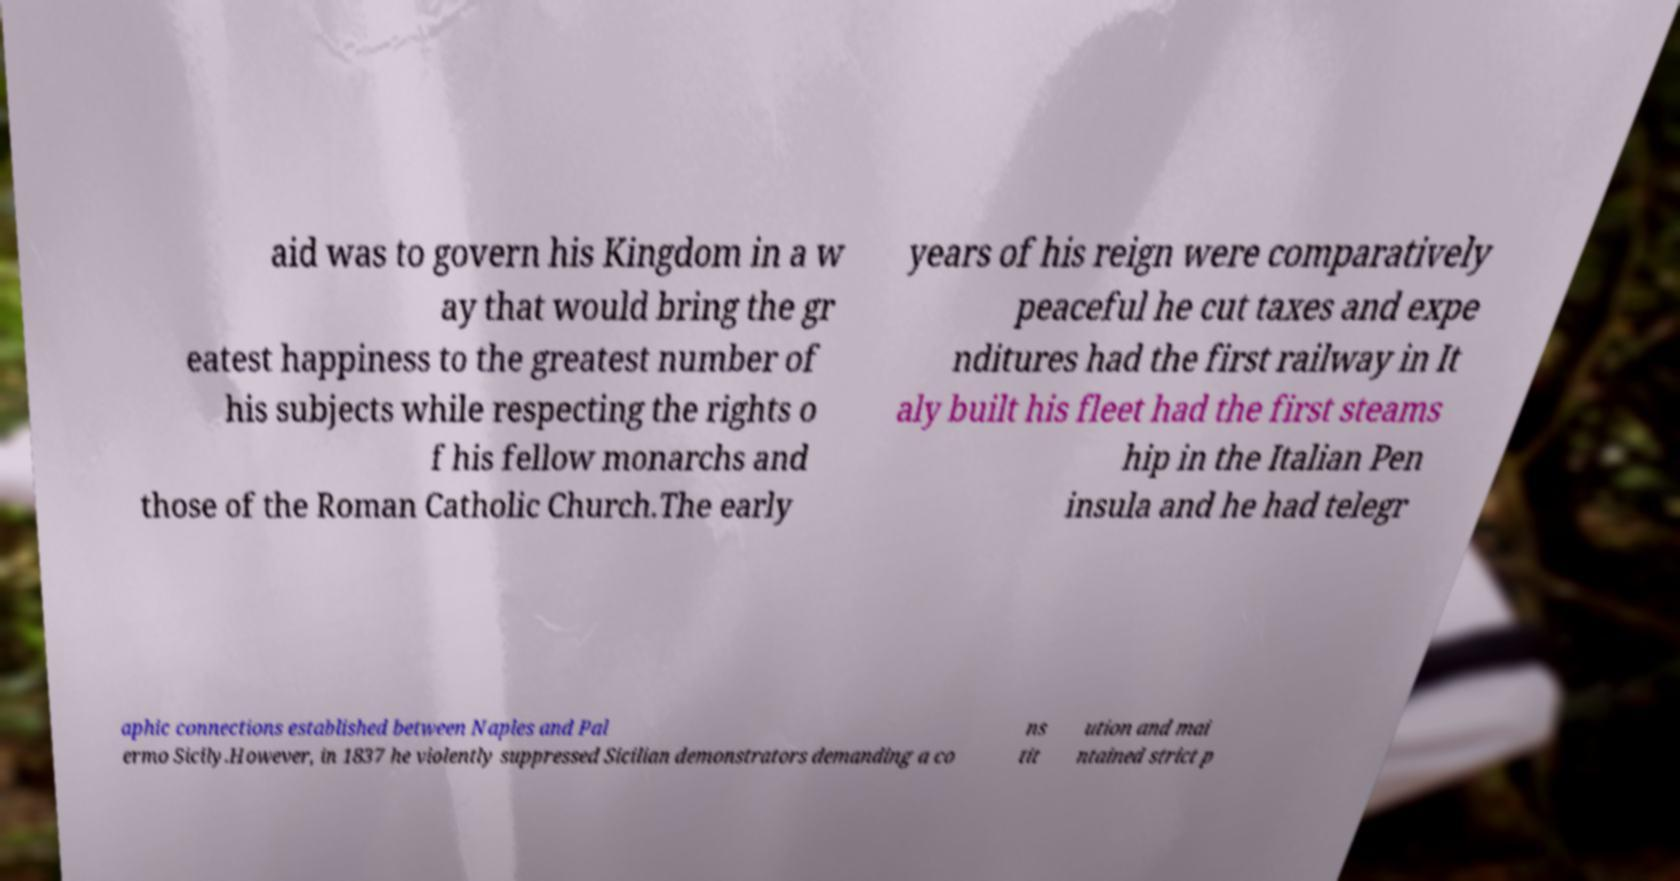There's text embedded in this image that I need extracted. Can you transcribe it verbatim? aid was to govern his Kingdom in a w ay that would bring the gr eatest happiness to the greatest number of his subjects while respecting the rights o f his fellow monarchs and those of the Roman Catholic Church.The early years of his reign were comparatively peaceful he cut taxes and expe nditures had the first railway in It aly built his fleet had the first steams hip in the Italian Pen insula and he had telegr aphic connections established between Naples and Pal ermo Sicily.However, in 1837 he violently suppressed Sicilian demonstrators demanding a co ns tit ution and mai ntained strict p 